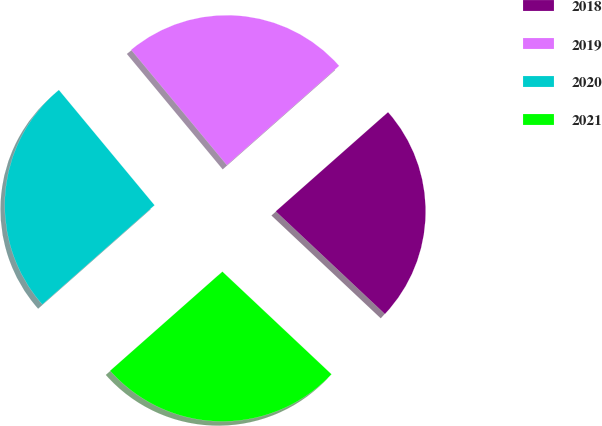Convert chart to OTSL. <chart><loc_0><loc_0><loc_500><loc_500><pie_chart><fcel>2018<fcel>2019<fcel>2020<fcel>2021<nl><fcel>23.53%<fcel>24.51%<fcel>25.49%<fcel>26.47%<nl></chart> 